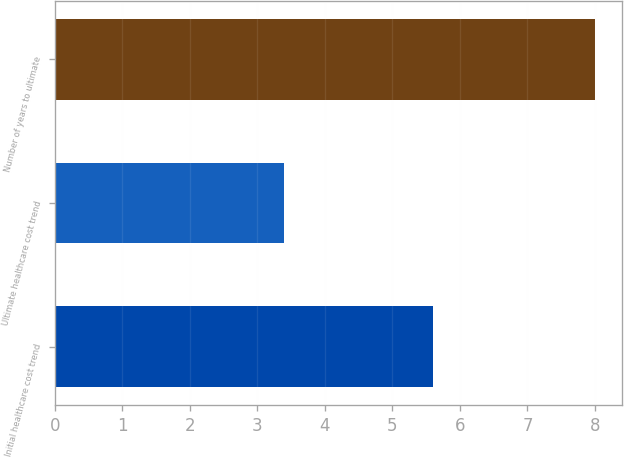Convert chart. <chart><loc_0><loc_0><loc_500><loc_500><bar_chart><fcel>Initial healthcare cost trend<fcel>Ultimate healthcare cost trend<fcel>Number of years to ultimate<nl><fcel>5.6<fcel>3.4<fcel>8<nl></chart> 